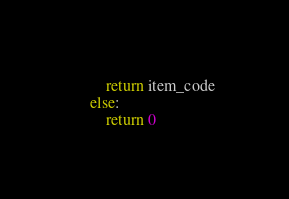Convert code to text. <code><loc_0><loc_0><loc_500><loc_500><_Python_>		return item_code
	else:
		return 0
</code> 